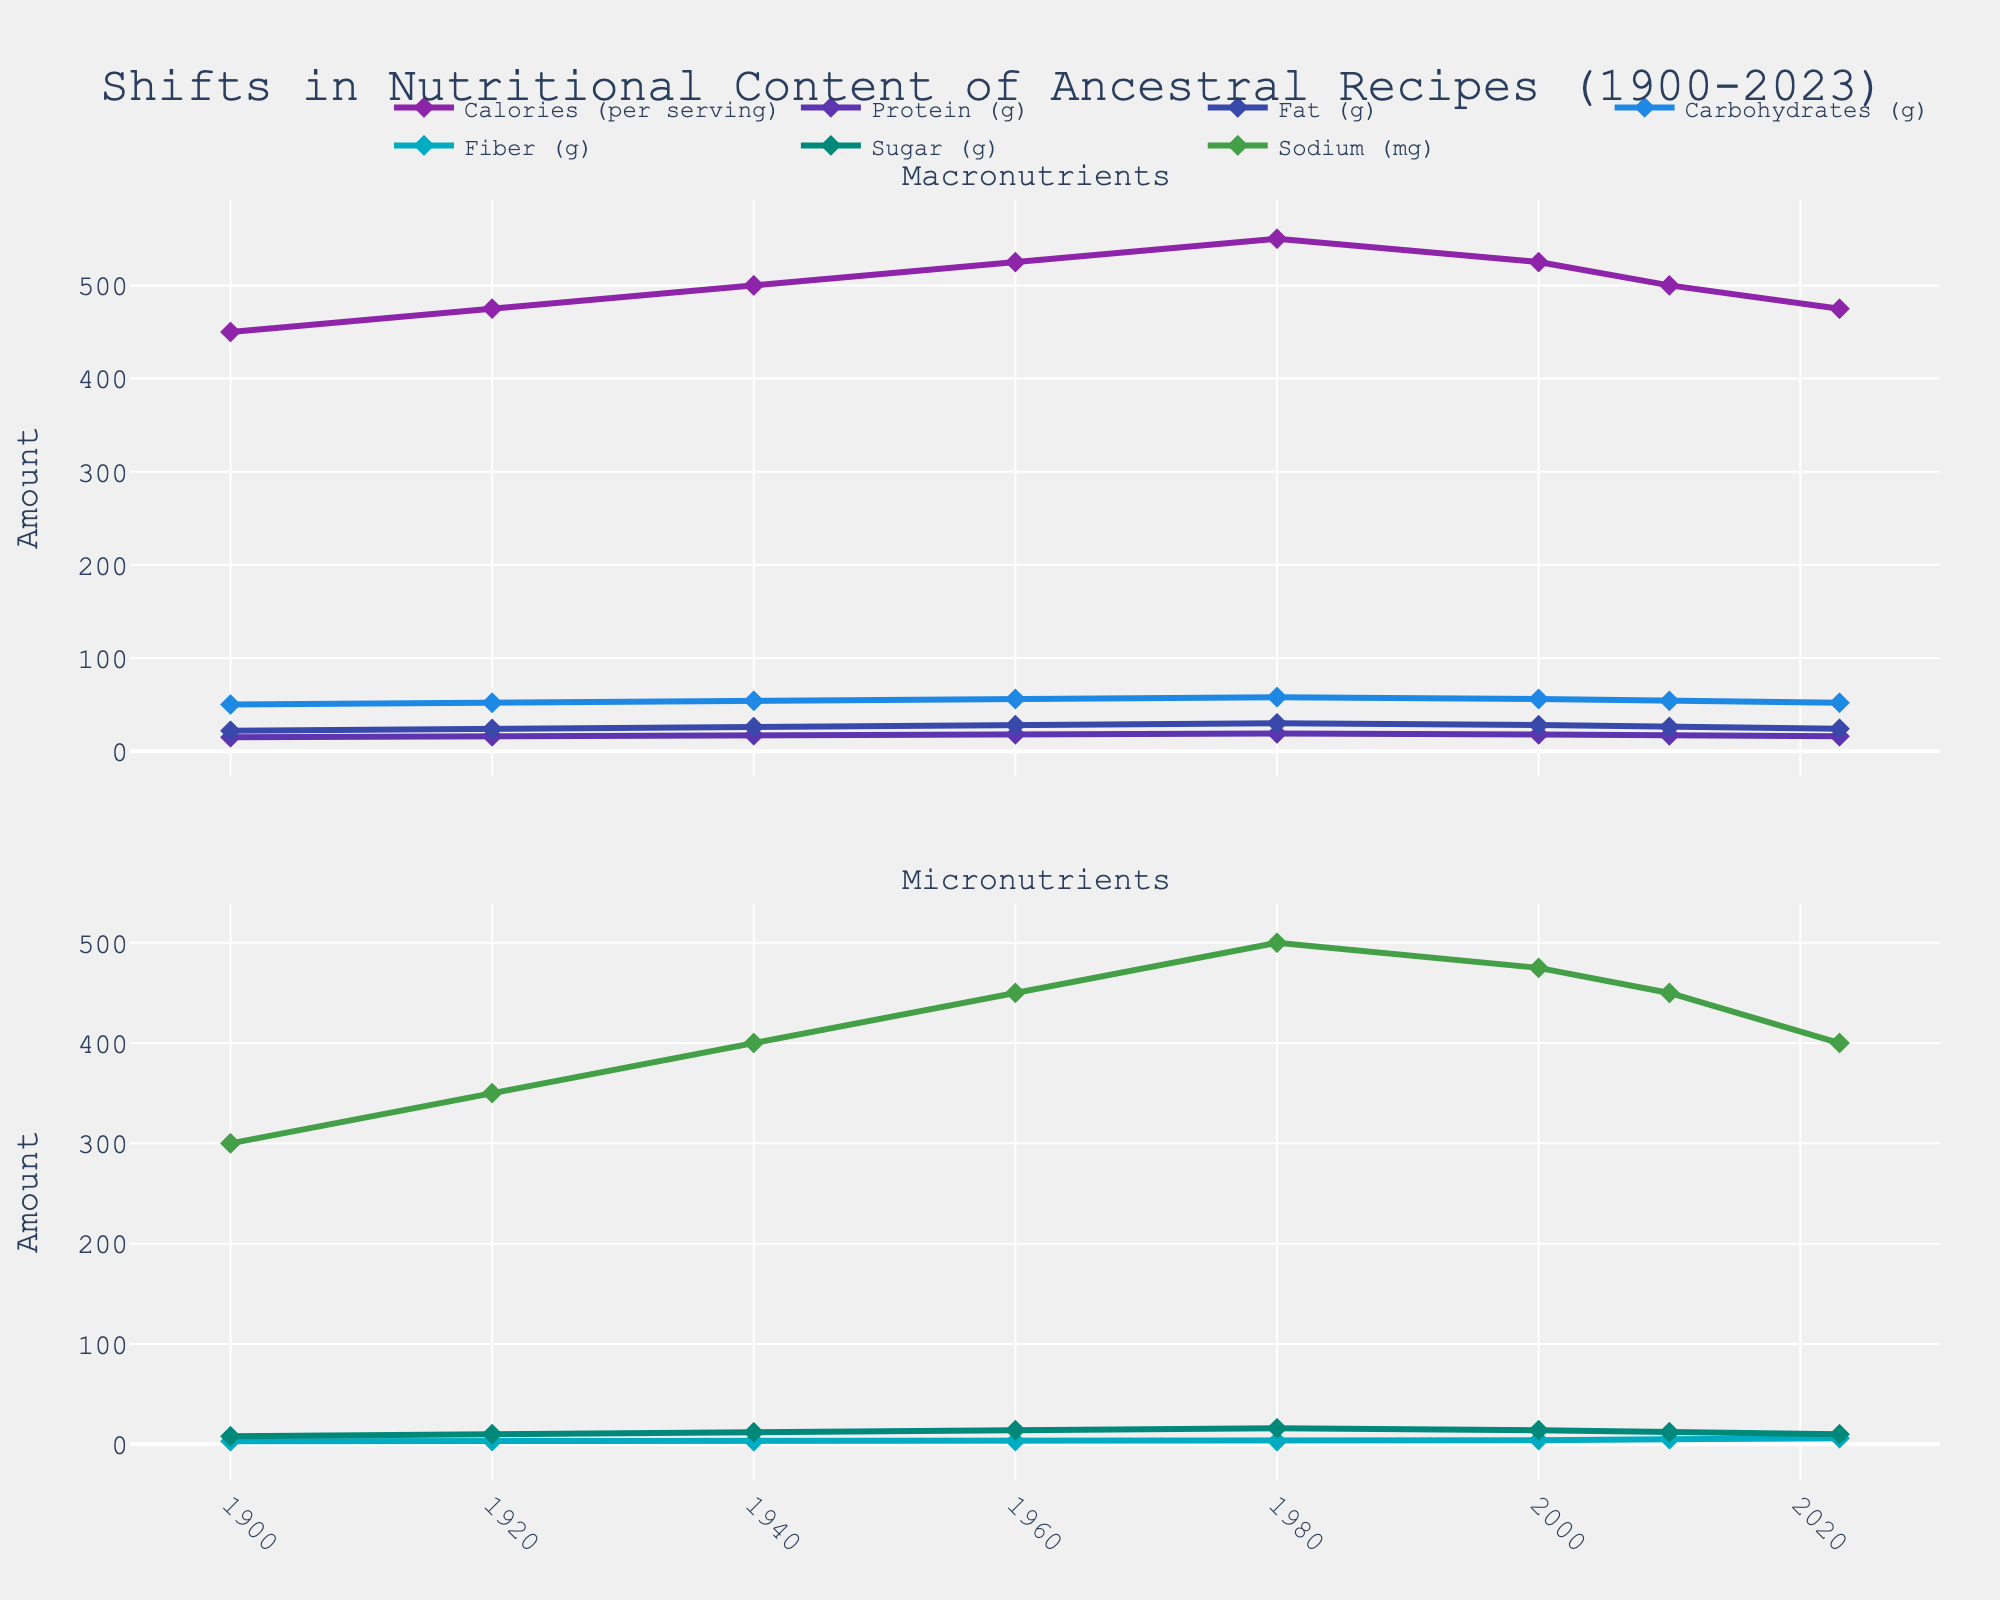What is the overall trend in calories per serving from 1900 to 2023? The calories per serving increased from 450 in 1900 to 550 in 1980. After 1980, there is a decrease in calories per serving to 475 in 2023.
Answer: Increased from 1900 to 1980, then decreased How has the amount of fiber per serving changed over the years? Fiber remained constant at 3g from 1900 to 1980, then increased gradually to 6g by 2023.
Answer: It increased Which year had the highest fat content per serving? The figure shows that the highest fat content per serving is in 1980, with 30g of fat.
Answer: 1980 Compare the trend of protein and carbohydrates from 1900 to 2023. Both protein and carbohydrates show an increasing trend from 1900 to 1980. After 1980, the protein content decreases slightly, while carbohydrates also decrease slightly but then stabilize.
Answer: Both increased until 1980, then decreased or stabilized Between which years did sugar content peak, and what was the peak value? Sugar content peaked in 1980 with a value of 16g per serving. The trend shows a gradual increase from 1900 to 1980.
Answer: 1980, 16g Which macronutrient shows the most consistent trend? The protein content shows the most consistent trend, gradually increasing from 15g in 1900 to 19g in 1980, then decreasing slightly but remaining relatively stable.
Answer: Protein What is the correlation between sodium content and year? Sodium content increased from 1900 to 1980, reaching a peak of 500mg. After 1980, it decreased but stayed higher than 1900 levels. There is an overall increasing trend until 1980, followed by a decline.
Answer: Positive until 1980, then negative How does the trend of fiber from 2000 to 2023 compare to the rest of the years? Fiber content increased gradually before 2000 but shows a more pronounced increase from 4g in 2000 to 6g in 2023.
Answer: More pronounced increase Which year had the lowest carbohydrates per serving, and what was the value? The lowest carbohydrates per serving were in 1900, with a value of 50g.
Answer: 1900, 50g 